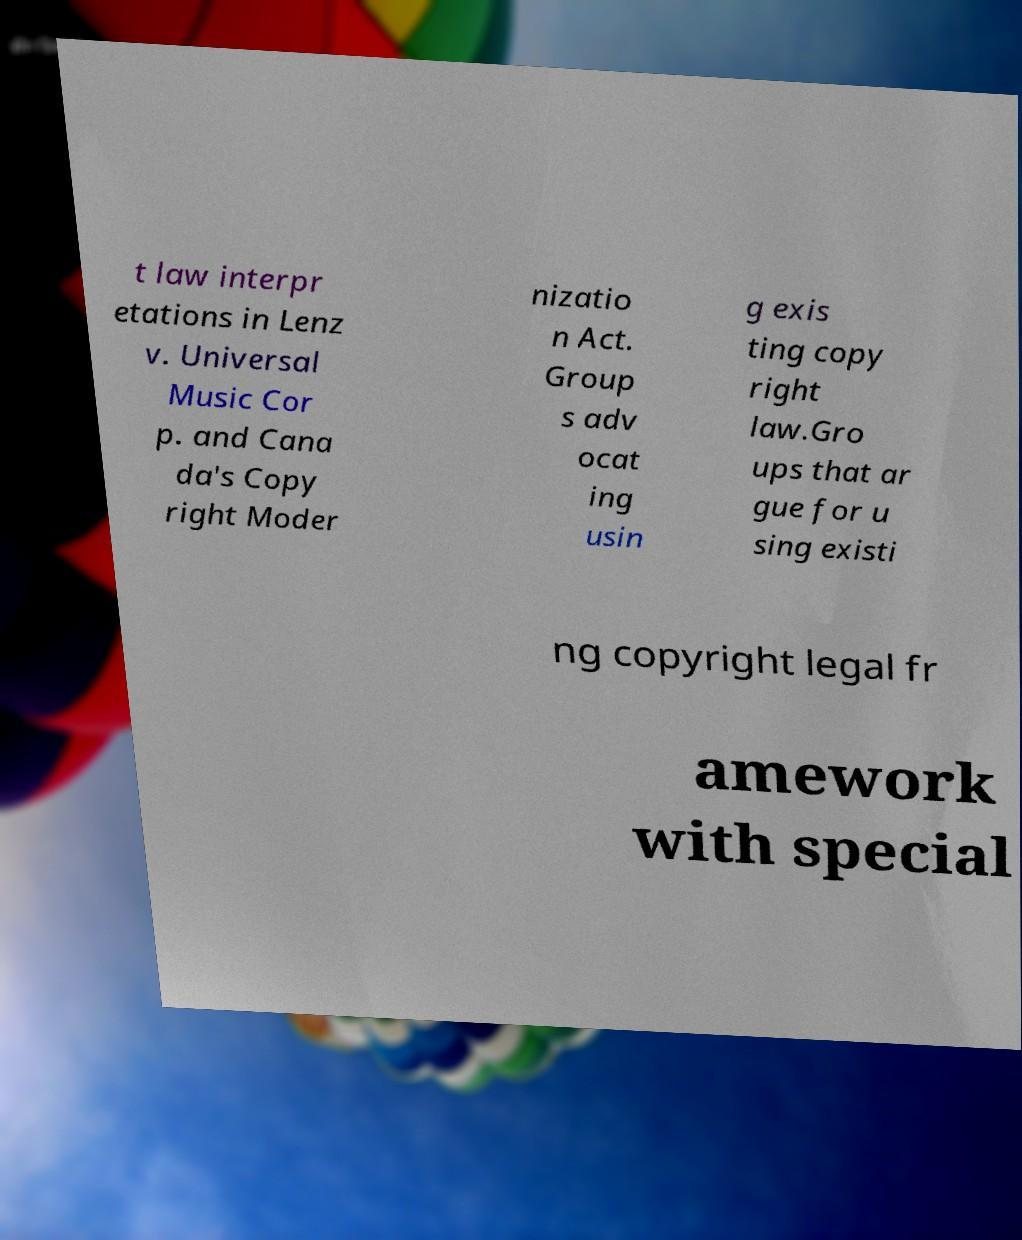Please identify and transcribe the text found in this image. t law interpr etations in Lenz v. Universal Music Cor p. and Cana da's Copy right Moder nizatio n Act. Group s adv ocat ing usin g exis ting copy right law.Gro ups that ar gue for u sing existi ng copyright legal fr amework with special 